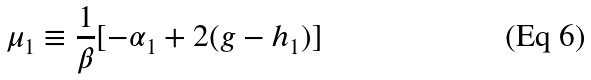<formula> <loc_0><loc_0><loc_500><loc_500>\mu _ { 1 } \equiv \frac { 1 } { \beta } [ - \alpha _ { 1 } + 2 ( g - h _ { 1 } ) ]</formula> 